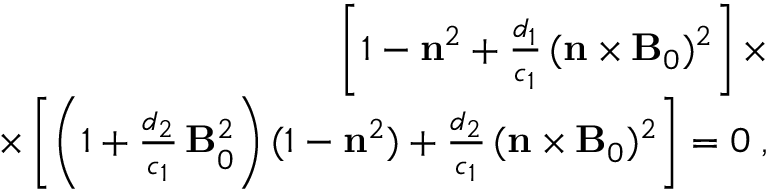<formula> <loc_0><loc_0><loc_500><loc_500>\begin{array} { r } { \left [ 1 - { n } ^ { 2 } + \frac { d _ { 1 } } { c _ { 1 } } \, ( { n } \times { B } _ { 0 } ) ^ { 2 } \right ] \times } \\ { \times \left [ \left ( 1 + \frac { d _ { 2 } } { c _ { 1 } } \, { B } _ { 0 } ^ { 2 } \right ) ( 1 - { n } ^ { 2 } ) + \frac { d _ { 2 } } { c _ { 1 } } \, ( { n } \times { B } _ { 0 } ) ^ { 2 } \right ] = 0 \, , } \end{array}</formula> 